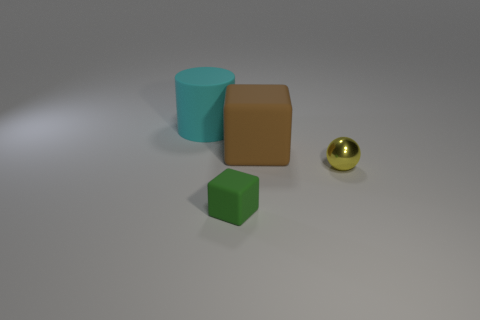What number of other things are made of the same material as the sphere?
Keep it short and to the point. 0. How many objects are shiny things or objects that are to the left of the large brown thing?
Your response must be concise. 3. Is the number of yellow spheres less than the number of blue things?
Your response must be concise. No. What is the color of the cube that is behind the rubber cube that is left of the large rubber object that is in front of the rubber cylinder?
Make the answer very short. Brown. Is the material of the large brown thing the same as the tiny green block?
Your answer should be compact. Yes. What number of brown matte objects are on the left side of the brown object?
Offer a terse response. 0. There is another object that is the same shape as the green thing; what is its size?
Provide a succinct answer. Large. How many yellow things are tiny matte objects or big cylinders?
Offer a very short reply. 0. There is a big object behind the large brown rubber object; how many green rubber blocks are on the left side of it?
Your answer should be very brief. 0. How many other things are there of the same shape as the yellow thing?
Offer a very short reply. 0. 